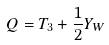<formula> <loc_0><loc_0><loc_500><loc_500>Q = T _ { 3 } + \frac { 1 } { 2 } Y _ { W }</formula> 